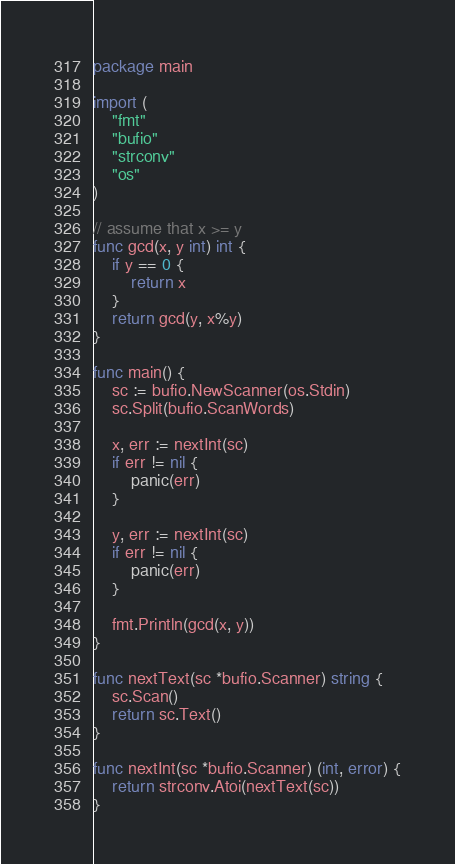Convert code to text. <code><loc_0><loc_0><loc_500><loc_500><_Go_>package main

import (
	"fmt"
	"bufio"
	"strconv"
	"os"
)

// assume that x >= y
func gcd(x, y int) int {
	if y == 0 {
		return x
	}
	return gcd(y, x%y)
}

func main() {
	sc := bufio.NewScanner(os.Stdin)
	sc.Split(bufio.ScanWords)

	x, err := nextInt(sc)
	if err != nil {
		panic(err)
	}

	y, err := nextInt(sc)
	if err != nil {
		panic(err)
	}

	fmt.Println(gcd(x, y))
}

func nextText(sc *bufio.Scanner) string {
	sc.Scan()
	return sc.Text()
}

func nextInt(sc *bufio.Scanner) (int, error) {
	return strconv.Atoi(nextText(sc))
}
</code> 